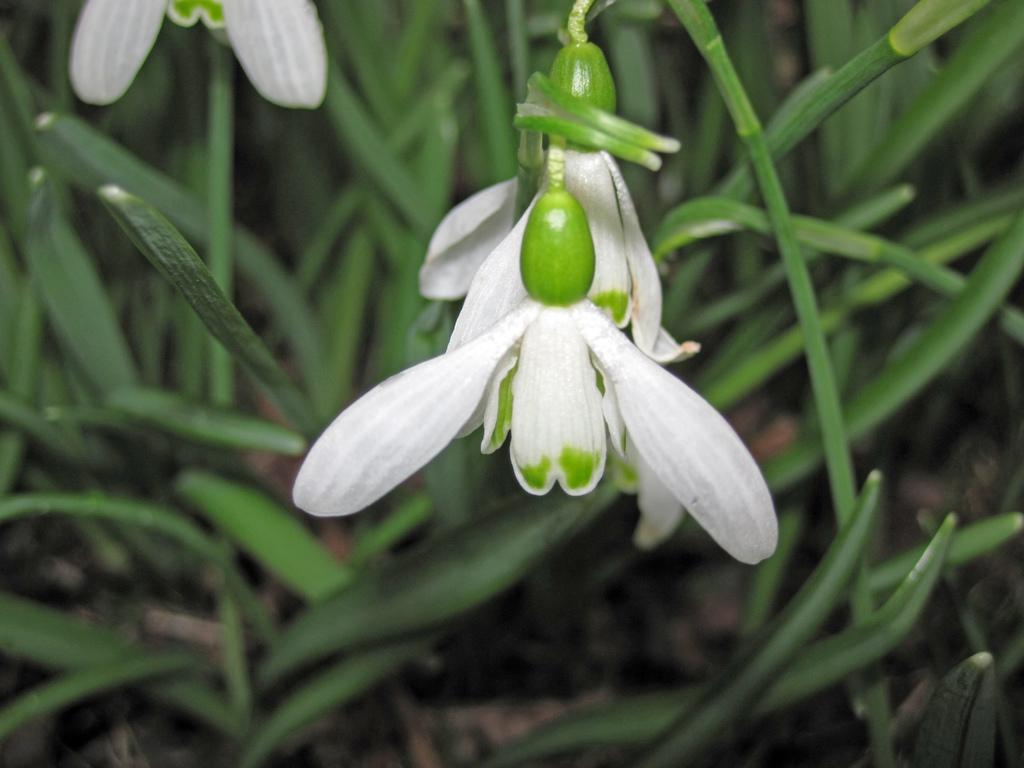What type of living organisms can be seen in the image? Plants and flowers are visible in the image. What color are the flowers in the image? The flowers in the image are white in color. What time of day is depicted in the image? The time of day is not visible in the image, as it only features plants and flowers. What type of scarf can be seen wrapped around the flowers in the image? There is no scarf present in the image; it only features plants and flowers. 